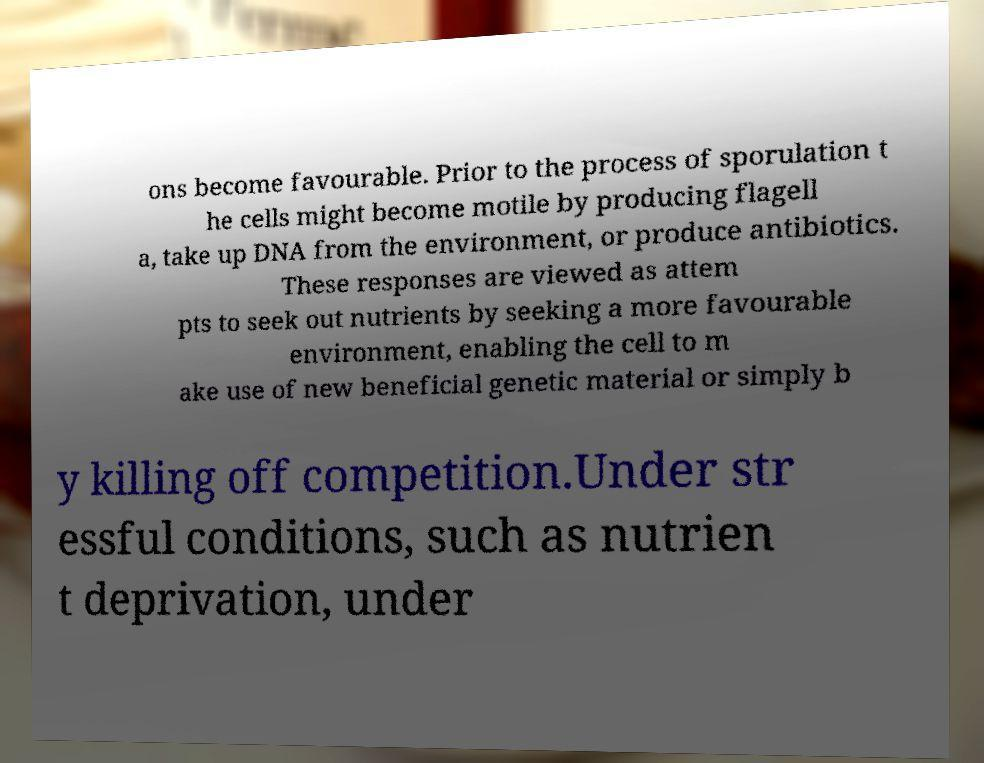Could you assist in decoding the text presented in this image and type it out clearly? ons become favourable. Prior to the process of sporulation t he cells might become motile by producing flagell a, take up DNA from the environment, or produce antibiotics. These responses are viewed as attem pts to seek out nutrients by seeking a more favourable environment, enabling the cell to m ake use of new beneficial genetic material or simply b y killing off competition.Under str essful conditions, such as nutrien t deprivation, under 